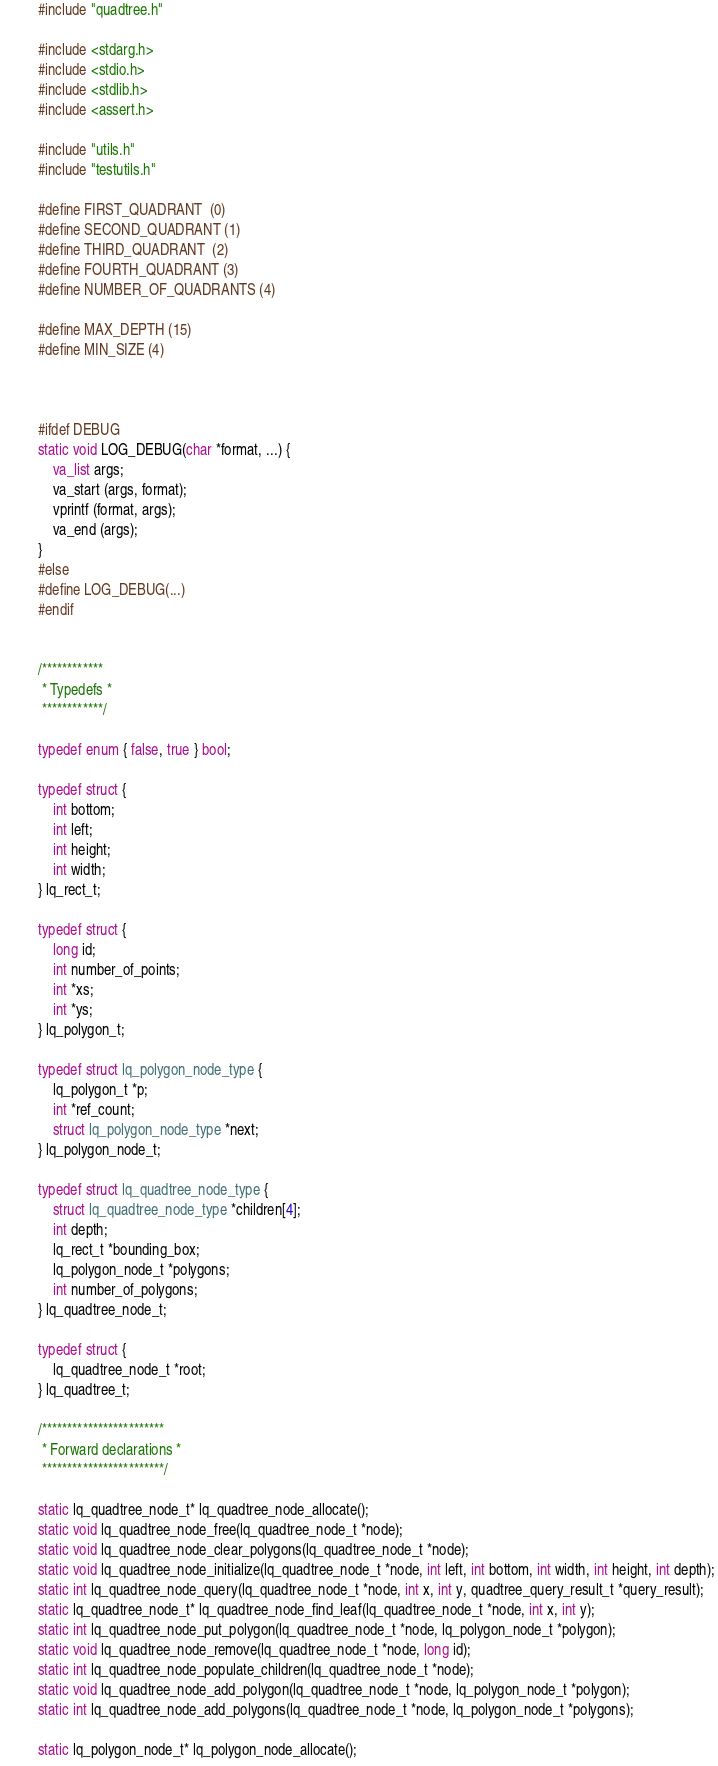Convert code to text. <code><loc_0><loc_0><loc_500><loc_500><_C_>#include "quadtree.h"

#include <stdarg.h>
#include <stdio.h>
#include <stdlib.h>
#include <assert.h>

#include "utils.h"
#include "testutils.h"

#define FIRST_QUADRANT  (0)
#define SECOND_QUADRANT (1)
#define THIRD_QUADRANT  (2)
#define FOURTH_QUADRANT (3)
#define NUMBER_OF_QUADRANTS (4)

#define MAX_DEPTH (15)
#define MIN_SIZE (4)



#ifdef DEBUG
static void LOG_DEBUG(char *format, ...) {
    va_list args;
    va_start (args, format);
    vprintf (format, args);
    va_end (args);
}
#else
#define LOG_DEBUG(...)
#endif


/************
 * Typedefs *
 ************/

typedef enum { false, true } bool;

typedef struct {
    int bottom;
    int left;
    int height;
    int width;
} lq_rect_t;

typedef struct {
    long id;
    int number_of_points;
    int *xs;
    int *ys;
} lq_polygon_t;

typedef struct lq_polygon_node_type {
    lq_polygon_t *p;
    int *ref_count;
    struct lq_polygon_node_type *next;
} lq_polygon_node_t;

typedef struct lq_quadtree_node_type {
    struct lq_quadtree_node_type *children[4];
    int depth;
    lq_rect_t *bounding_box;
    lq_polygon_node_t *polygons;
    int number_of_polygons;
} lq_quadtree_node_t;

typedef struct {
    lq_quadtree_node_t *root;
} lq_quadtree_t;

/************************
 * Forward declarations *
 ************************/

static lq_quadtree_node_t* lq_quadtree_node_allocate();
static void lq_quadtree_node_free(lq_quadtree_node_t *node);
static void lq_quadtree_node_clear_polygons(lq_quadtree_node_t *node);
static void lq_quadtree_node_initialize(lq_quadtree_node_t *node, int left, int bottom, int width, int height, int depth);
static int lq_quadtree_node_query(lq_quadtree_node_t *node, int x, int y, quadtree_query_result_t *query_result);
static lq_quadtree_node_t* lq_quadtree_node_find_leaf(lq_quadtree_node_t *node, int x, int y);
static int lq_quadtree_node_put_polygon(lq_quadtree_node_t *node, lq_polygon_node_t *polygon);
static void lq_quadtree_node_remove(lq_quadtree_node_t *node, long id);
static int lq_quadtree_node_populate_children(lq_quadtree_node_t *node);
static void lq_quadtree_node_add_polygon(lq_quadtree_node_t *node, lq_polygon_node_t *polygon);
static int lq_quadtree_node_add_polygons(lq_quadtree_node_t *node, lq_polygon_node_t *polygons);

static lq_polygon_node_t* lq_polygon_node_allocate();</code> 